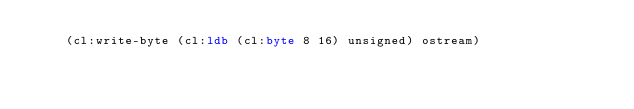Convert code to text. <code><loc_0><loc_0><loc_500><loc_500><_Lisp_>    (cl:write-byte (cl:ldb (cl:byte 8 16) unsigned) ostream)</code> 